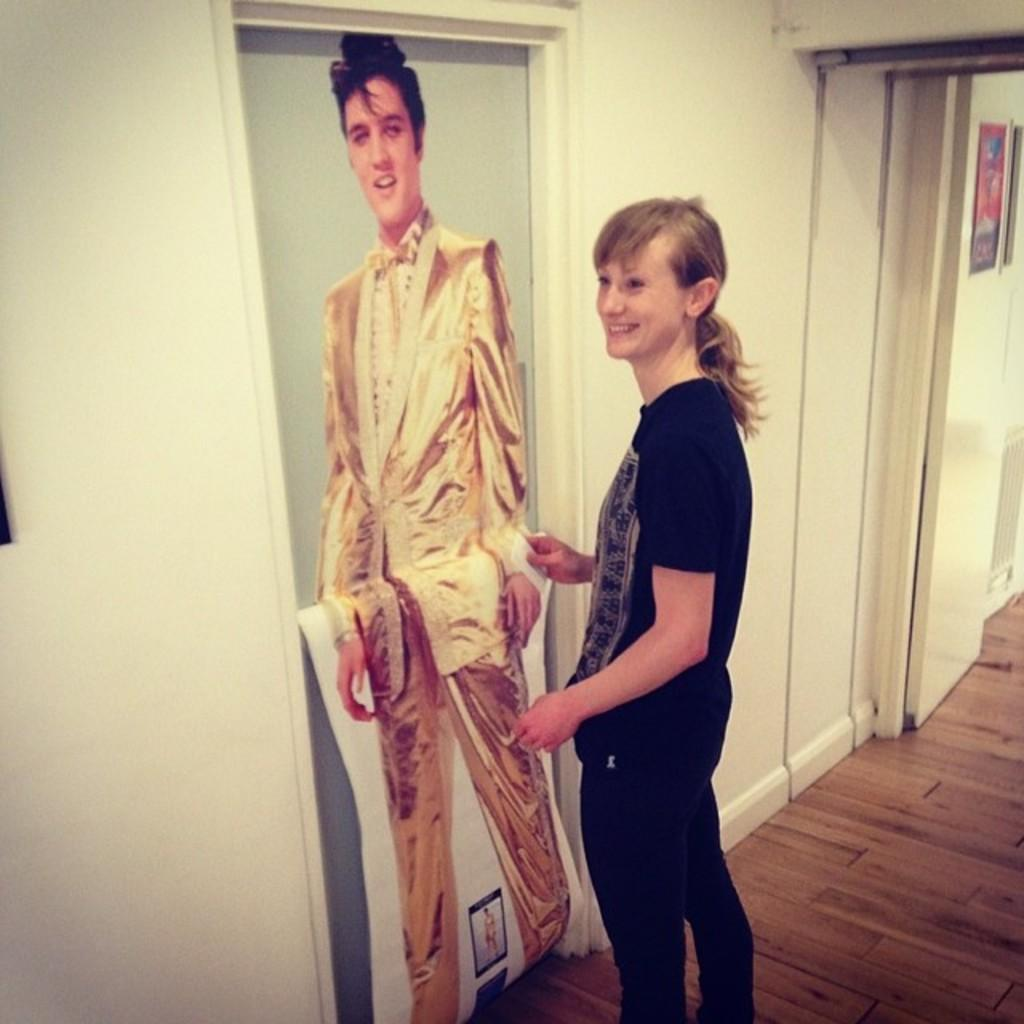Who or what is present in the image? There is a person in the image. What is the person's position in the image? The person is on the floor. What can be seen on the door in front of the person? There is a photo or poster on the door in front of the person. What is visible behind the person? There is a wall visible in the image. What type of vein is visible on the person's arm in the image? There is no visible vein on the person's arm in the image. How does the person's body interact with the floor in terms of friction? The image does not provide enough information to determine the friction between the person's body and the floor. 